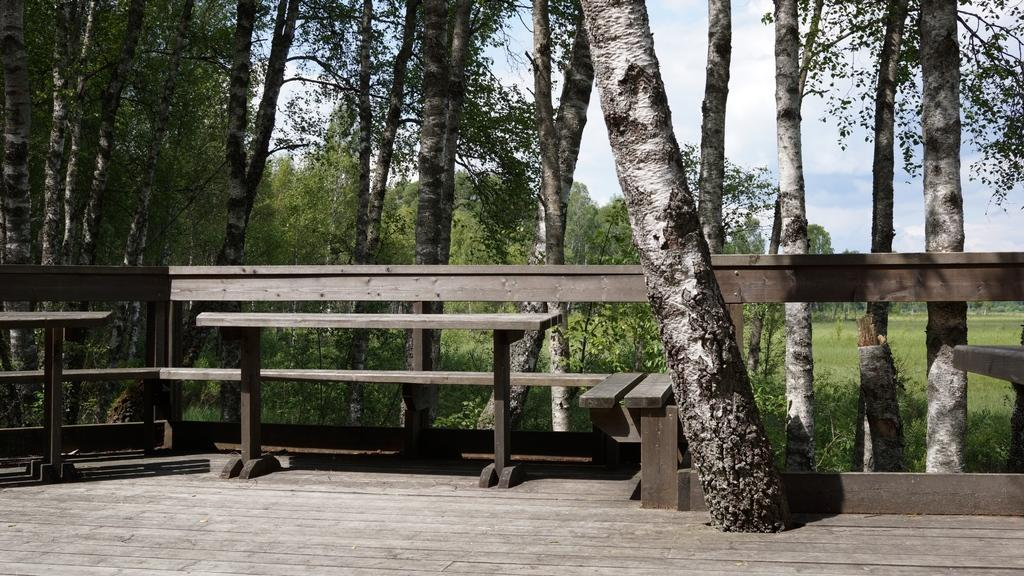What type of material is used for the fencing and bench in the image? The fencing and bench in the image are made of wood. What can be seen behind the wooden fencing and bench? A: There are trees behind the wooden fencing and bench. What is the condition of the land in the image? The land is full of grass. How would you describe the sky in the image? The sky is blue with some clouds. What type of ball is being used in the winter scene depicted in the image? There is no winter scene or ball present in the image; it features a wooden fencing, bench, trees, grass, and a blue sky with clouds. 